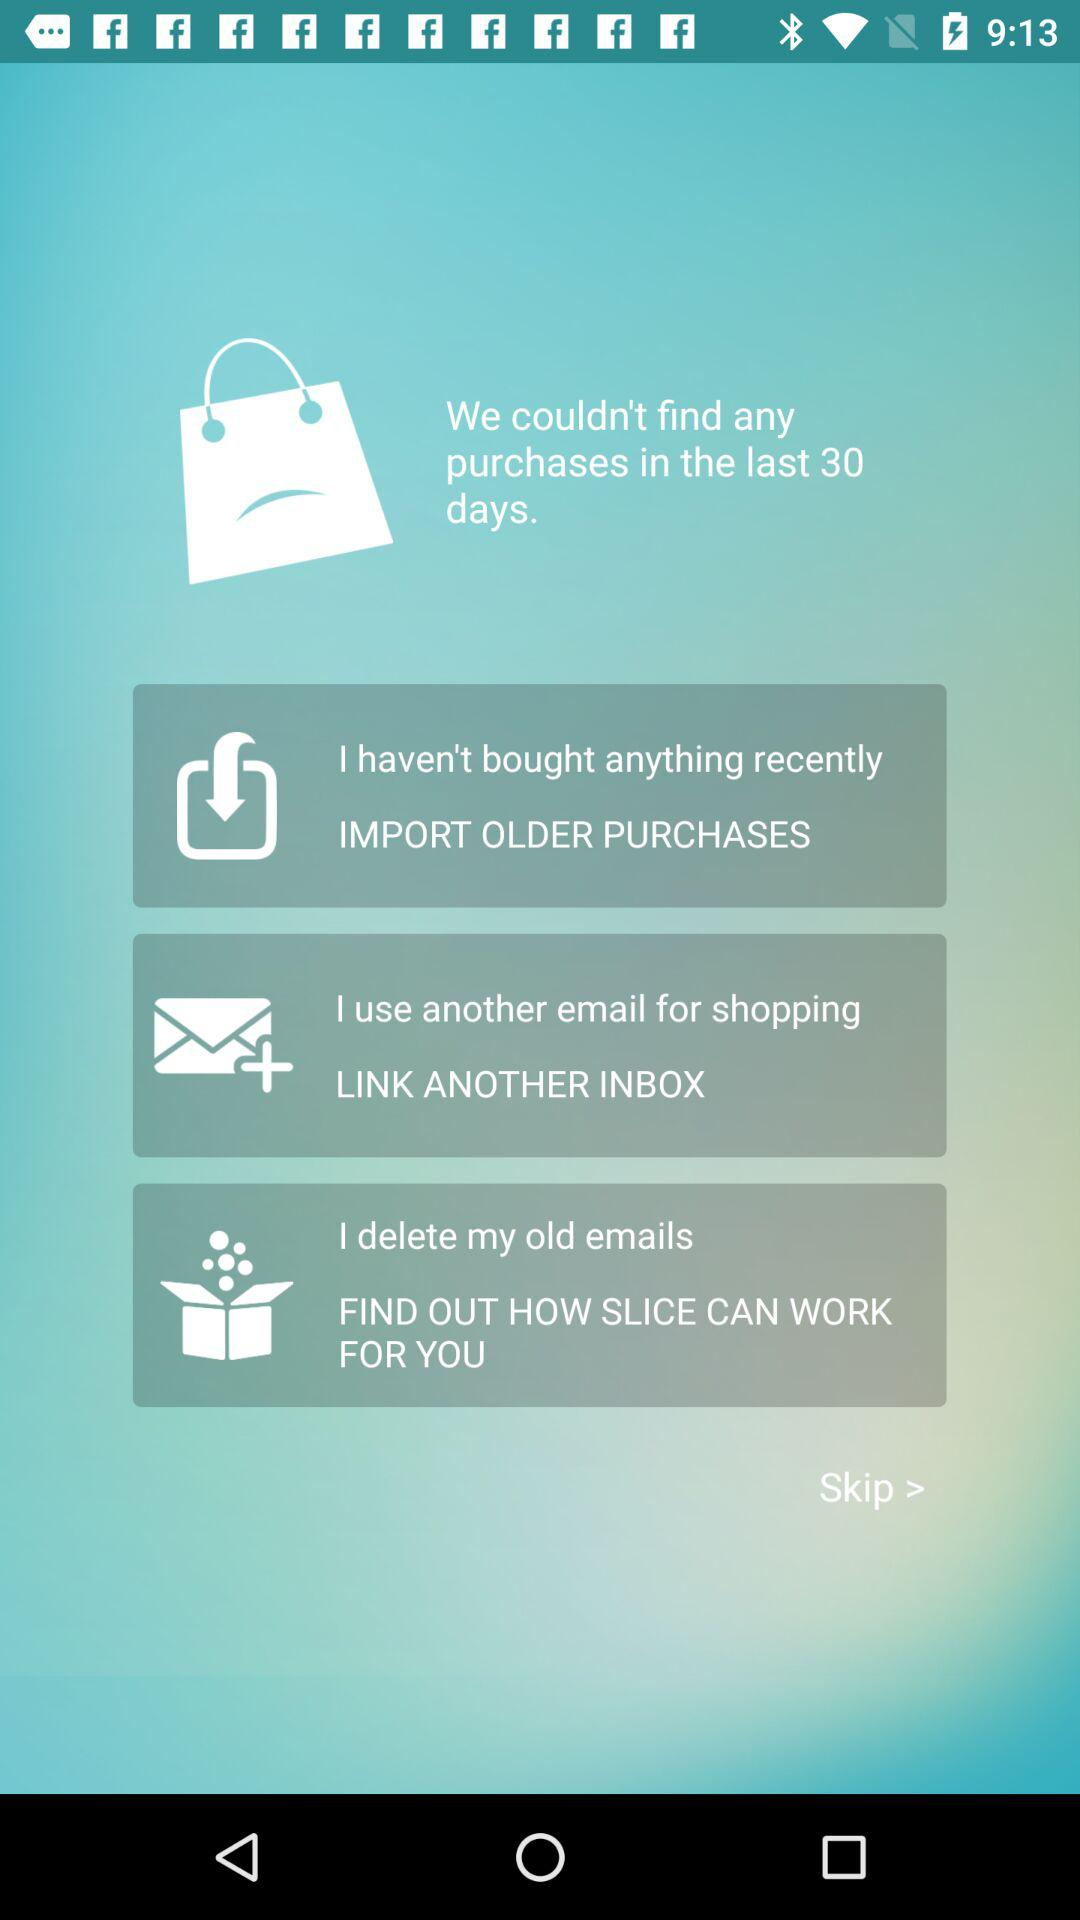How many days have passed since the last purchase? Since the last purchase, there have been 30 days that have passed. 